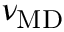<formula> <loc_0><loc_0><loc_500><loc_500>\nu _ { M D }</formula> 